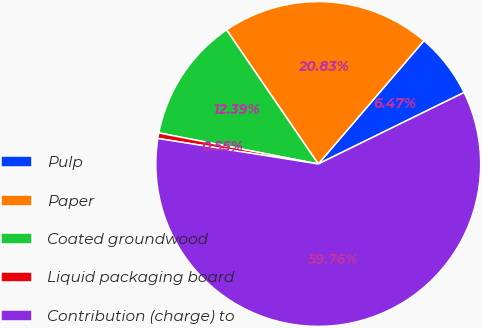<chart> <loc_0><loc_0><loc_500><loc_500><pie_chart><fcel>Pulp<fcel>Paper<fcel>Coated groundwood<fcel>Liquid packaging board<fcel>Contribution (charge) to<nl><fcel>6.47%<fcel>20.83%<fcel>12.39%<fcel>0.55%<fcel>59.77%<nl></chart> 